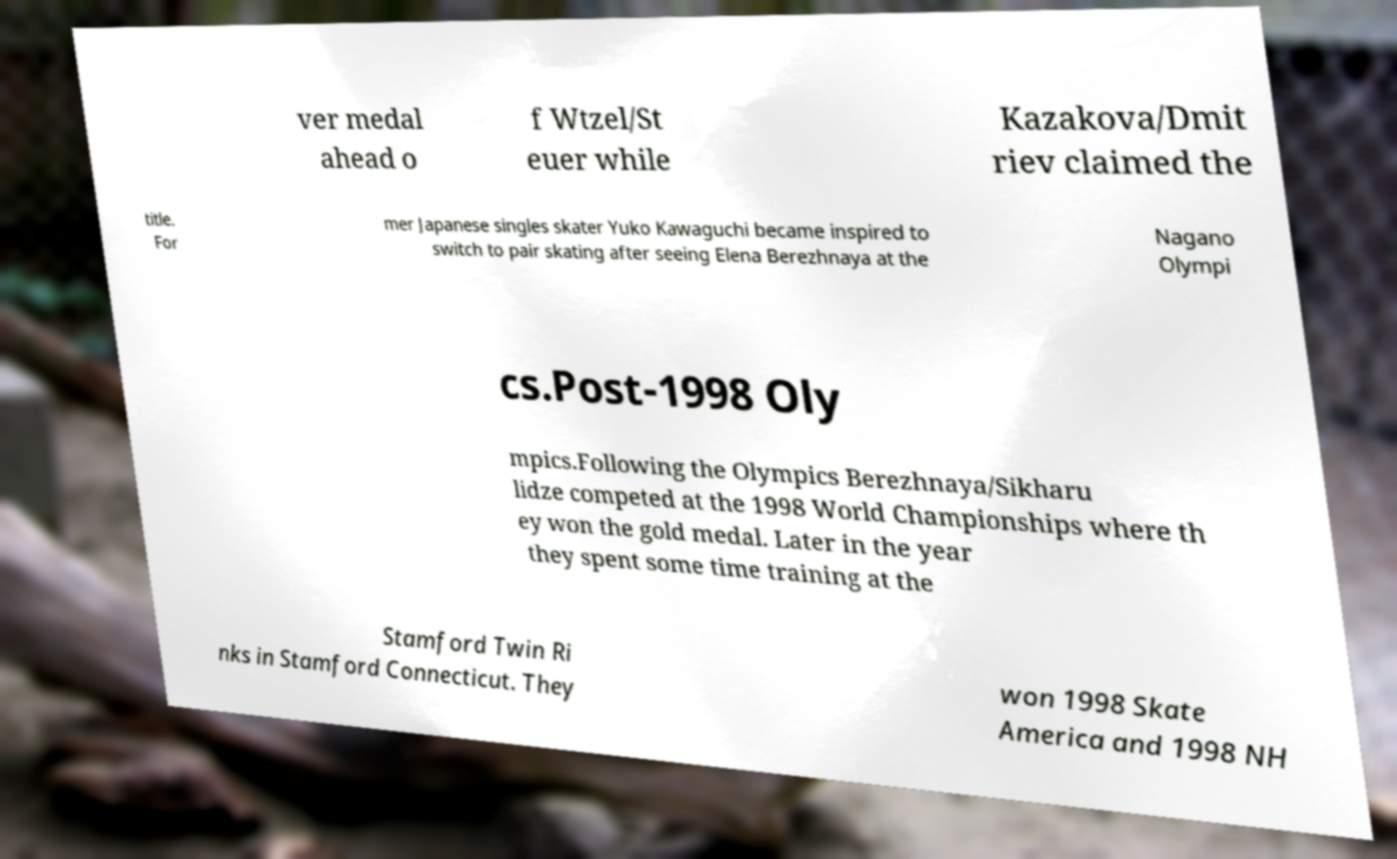Could you extract and type out the text from this image? ver medal ahead o f Wtzel/St euer while Kazakova/Dmit riev claimed the title. For mer Japanese singles skater Yuko Kawaguchi became inspired to switch to pair skating after seeing Elena Berezhnaya at the Nagano Olympi cs.Post-1998 Oly mpics.Following the Olympics Berezhnaya/Sikharu lidze competed at the 1998 World Championships where th ey won the gold medal. Later in the year they spent some time training at the Stamford Twin Ri nks in Stamford Connecticut. They won 1998 Skate America and 1998 NH 